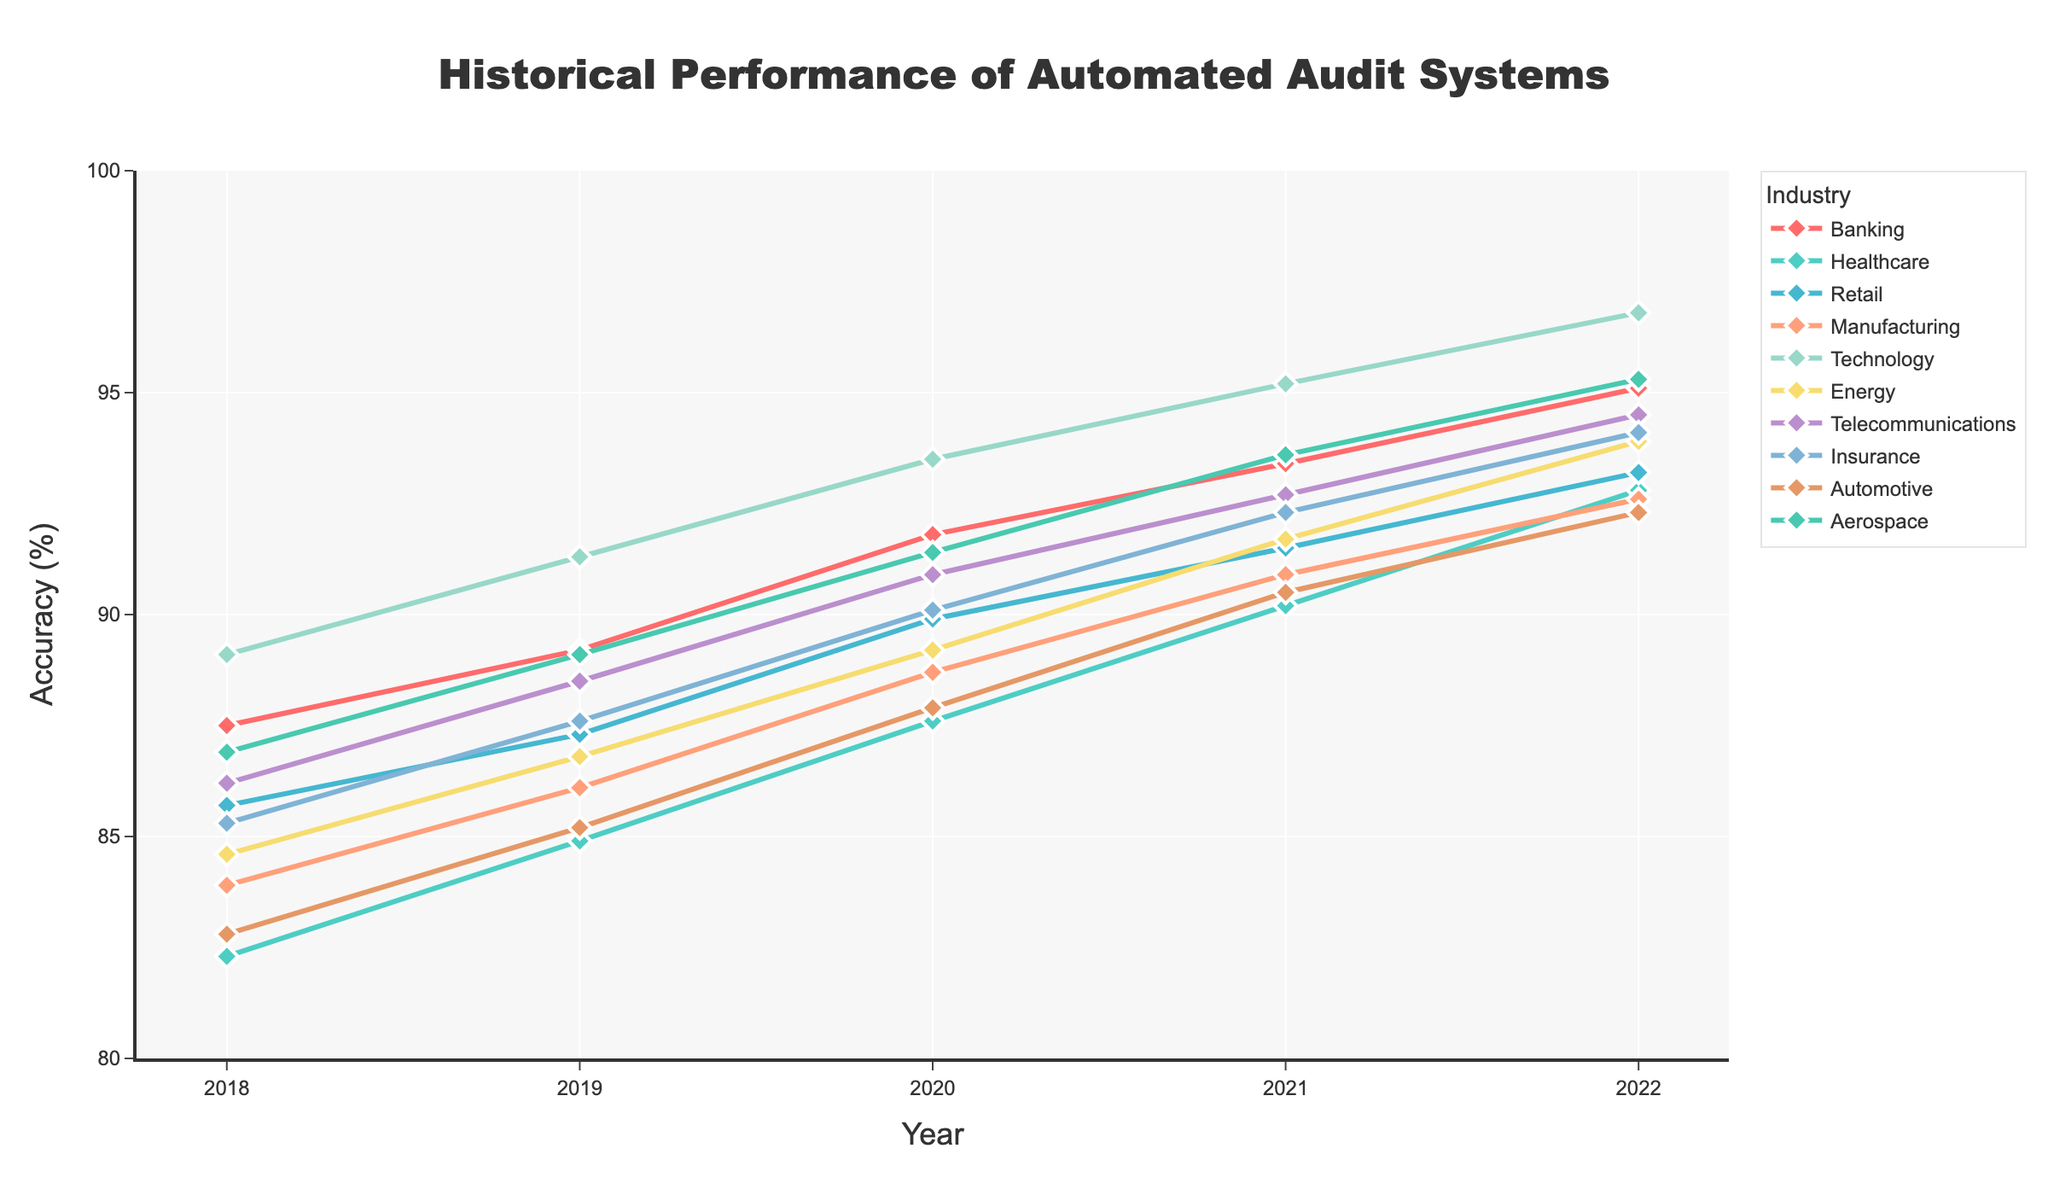What industry has the highest accuracy rate in 2022? To find the industry with the highest accuracy rate in 2022, look at the y-values of all lines in the figure for the year 2022. The one with the highest point represents the industry with the highest accuracy. Technology has the highest accuracy rate of 96.8%.
Answer: Technology What is the average accuracy rate for the Retail industry from 2018 to 2022? To find the average accuracy rate for the Retail industry, sum the accuracy rates for the years 2018-2022 and divide by the number of years. (85.7 + 87.3 + 89.9 + 91.5 + 93.2) / 5 = 89.52%.
Answer: 89.5% Which industry showed the most improvement in accuracy rate from 2018 to 2022? To determine the industry with the most improvement, compute the difference between the accuracy rates in 2022 and 2018 for each industry, then compare these values. Technology showed the most improvement with an increase of 7.7% (96.8% - 89.1%).
Answer: Technology Which year shows the smallest overall accuracy rate difference between the Banking and Healthcare industries? Compute the absolute differences in accuracy rates between Banking and Healthcare for each year and then identify the year with the smallest difference. Differences are: 2018: 87.5-82.3=5.2, 2019: 89.2-84.9=4.3, 2020: 91.8-87.6=4.2, 2021: 93.4-90.2=3.2, 2022: 95.1-92.8=2.3. The smallest difference occurs in 2022.
Answer: 2022 What has been the trend in accuracy rates for the Energy industry over the years? To identify the trend, observe the changes in the accuracy rates for the Energy industry from 2018 to 2022. The line for Energy shows increasing values each year: 84.6, 86.8, 89.2, 91.7, 93.9. This indicates a steadily upward trend.
Answer: Upward trend How does the average accuracy rate for the Healthcare industry compare to that of the Automotive industry from 2018 to 2022? Compute the average accuracy rate for both industries by summing their rates over the years 2018-2022 and dividing by the number of years. Healthcare: (82.3+84.9+87.6+90.2+92.8)/5 = 87.56%. Automotive: (82.8+85.2+87.9+90.5+92.3)/5 = 87.74%. The difference is minor, with Automotive having a slightly higher average.
Answer: Automotive Which industry had the highest accuracy rate in 2018? Look at the y-values for each industry in the year 2018. The highest point corresponds to the Technology industry with an accuracy rate of 89.1%.
Answer: Technology Which two industries had the closest accuracy rates in 2020? To find the closest accuracy rates in 2020, compare the values for each industry and compute the absolute differences. The closest values are Retail (89.9) and Insurance (90.1) with a difference of 0.2%.
Answer: Retail and Insurance 